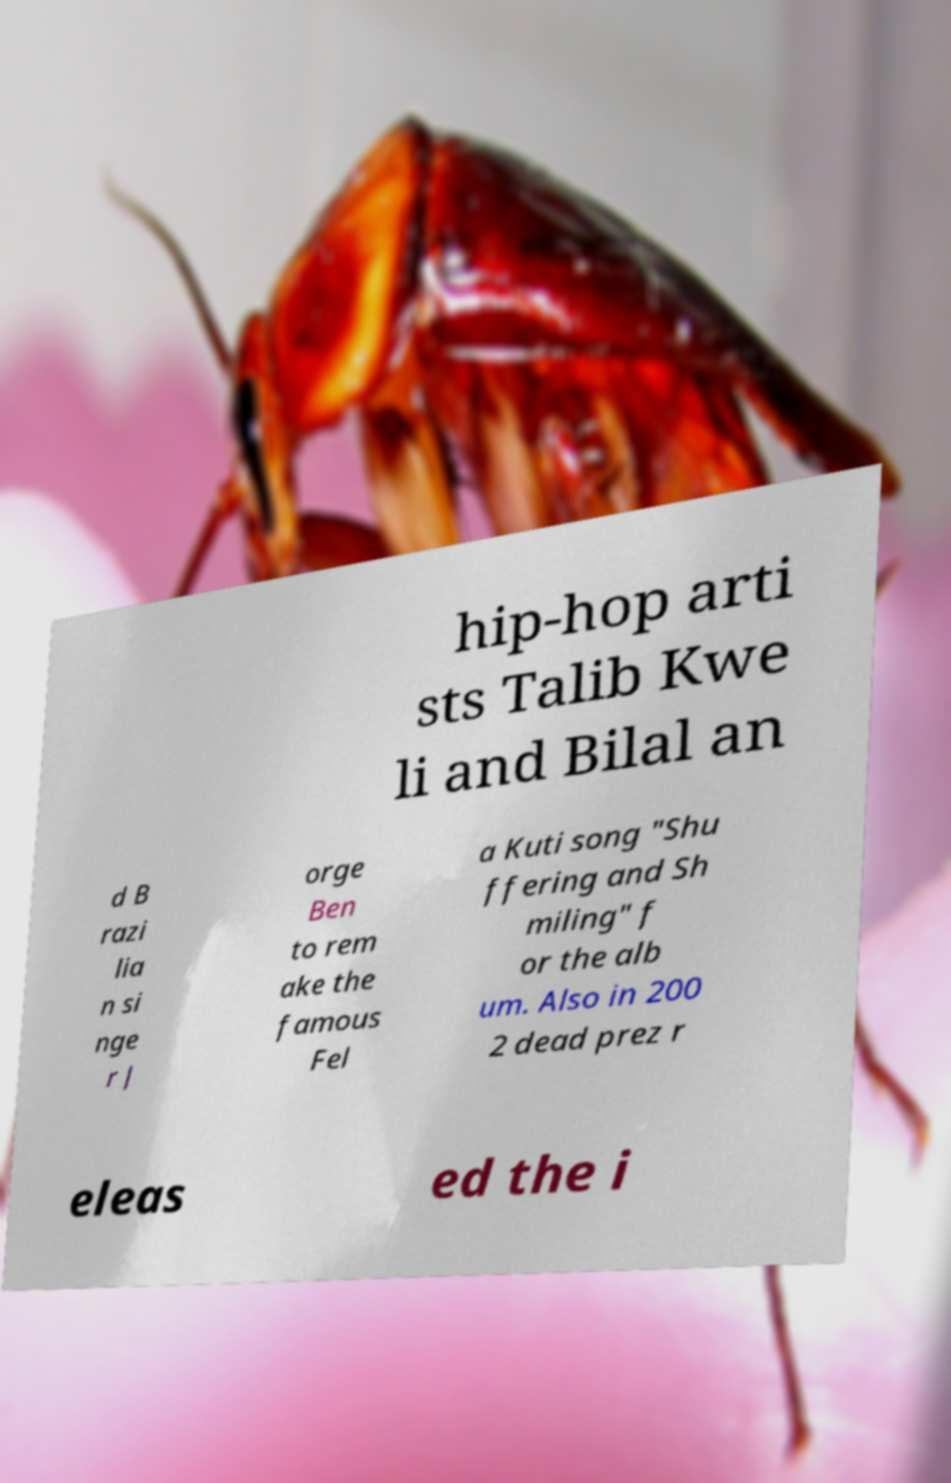Can you accurately transcribe the text from the provided image for me? hip-hop arti sts Talib Kwe li and Bilal an d B razi lia n si nge r J orge Ben to rem ake the famous Fel a Kuti song "Shu ffering and Sh miling" f or the alb um. Also in 200 2 dead prez r eleas ed the i 